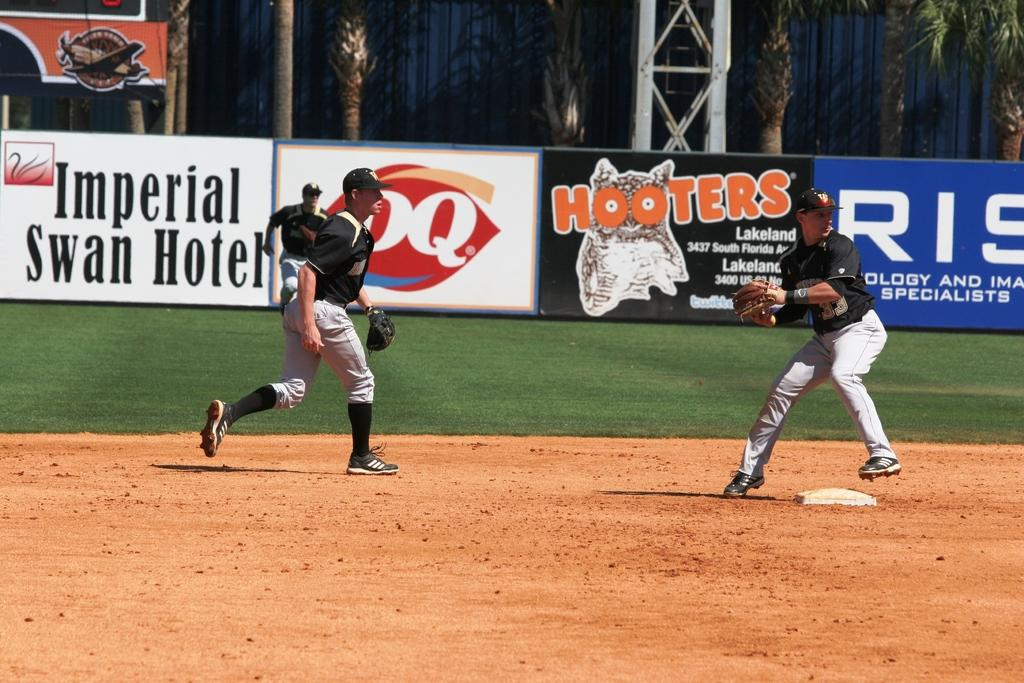<image>
Create a compact narrative representing the image presented. A baseball game with an advertisement for Hooters in the background. 